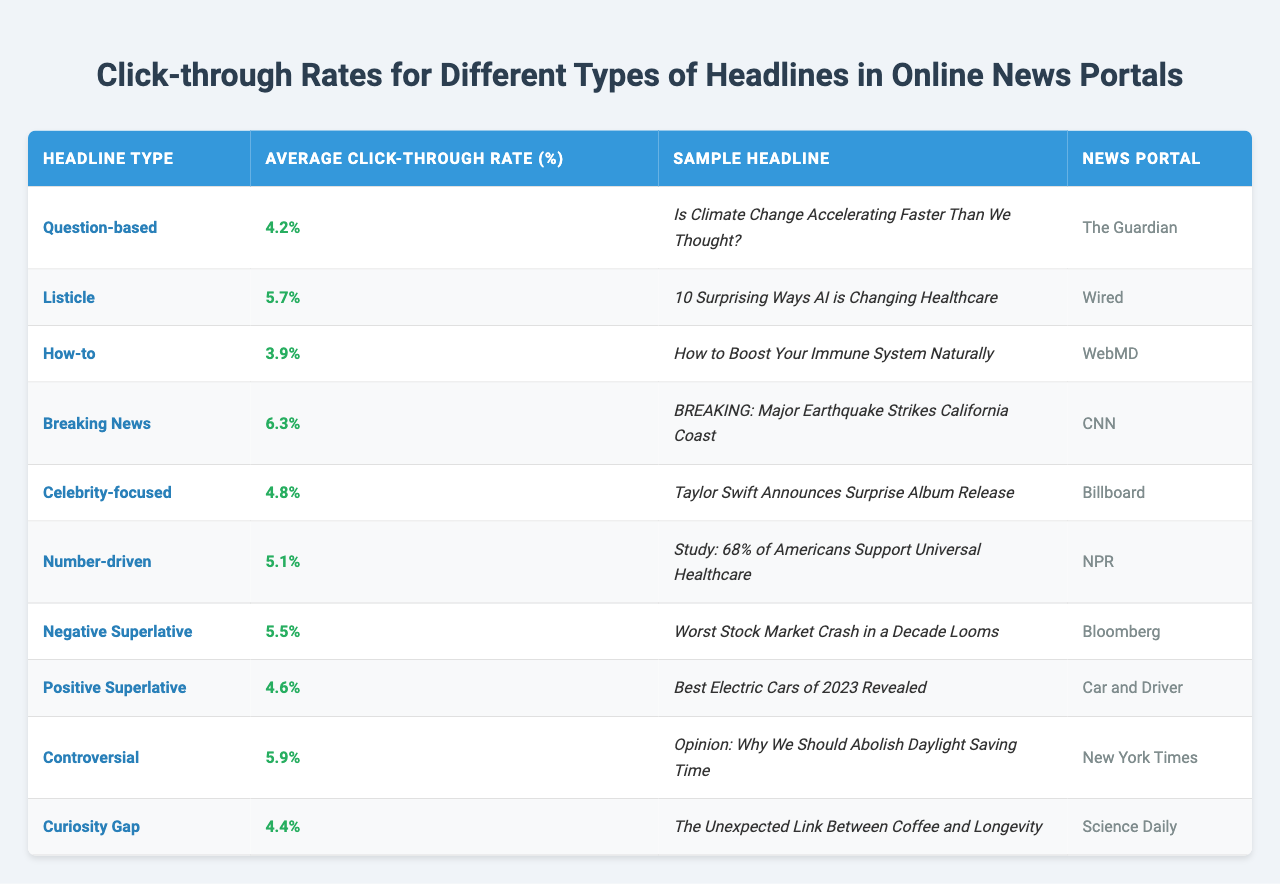What headline type has the highest average click-through rate? By scanning the "Average Click-Through Rate (%)" column, we see that "Breaking News" has the highest rate at 6.3%.
Answer: Breaking News What is the average click-through rate for listicle headlines? The average click-through rate for listicle headlines is mentioned as 5.7% in the table.
Answer: 5.7% Is the average click-through rate for question-based headlines higher than that of how-to headlines? The average click-through rate for question-based headlines is 4.2% and for how-to headlines is 3.9%. Since 4.2% is greater than 3.9%, the statement is true.
Answer: Yes What is the combined average click-through rate for negative superlative and positive superlative headlines? The rates for negative superlative and positive superlative are 5.5% and 4.6% respectively. To find the combined average: (5.5 + 4.6) / 2 = 5.05%.
Answer: 5.05% Which news portal features the sample headline "Study: 68% of Americans Support Universal Healthcare"? The "News Portal" column indicates that the sample headline is featured by NPR.
Answer: NPR How many headline types have an average click-through rate above 5%? By reviewing the average click-through rates, we can see that there are 5 headline types above 5%: Listicle, Breaking News, Controversial, Negative Superlative, and Number-driven.
Answer: 5 Are headlines that focus on celebrity news generally more effective than how-to headlines in terms of click-through rates? The average click-through rate for celebrity-focused headlines is 4.8% while for how-to headlines it is 3.9%. Since 4.8% is higher than 3.9%, celebrity-focused headlines are generally more effective.
Answer: Yes What is the difference in average click-through rate between negative superlative and curiosity gap headlines? The average click-through rate for negative superlative headlines is 5.5% and for curiosity gap headlines, it is 4.4%. The difference is 5.5% - 4.4% = 1.1%.
Answer: 1.1% Which headline type has the lowest average click-through rate? By examining the table, "How-to" headlines have the lowest average click-through rate at 3.9%.
Answer: How-to What pattern can you observe between the type of headline and the average click-through rate? More sensational or urgent headline types like "Breaking News" and "Controversial" tend to have higher click-through rates compared to more informational types like "How-to."
Answer: Sensational types tend to have higher rates 